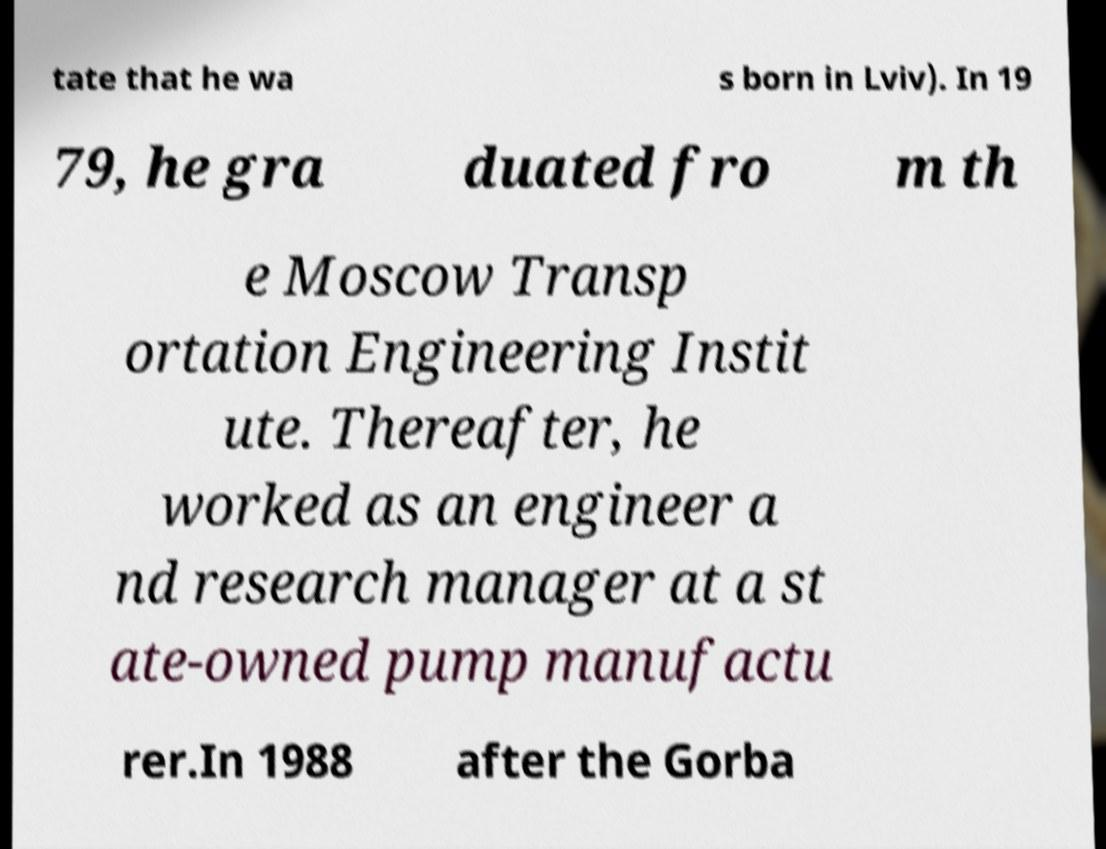Please read and relay the text visible in this image. What does it say? tate that he wa s born in Lviv). In 19 79, he gra duated fro m th e Moscow Transp ortation Engineering Instit ute. Thereafter, he worked as an engineer a nd research manager at a st ate-owned pump manufactu rer.In 1988 after the Gorba 